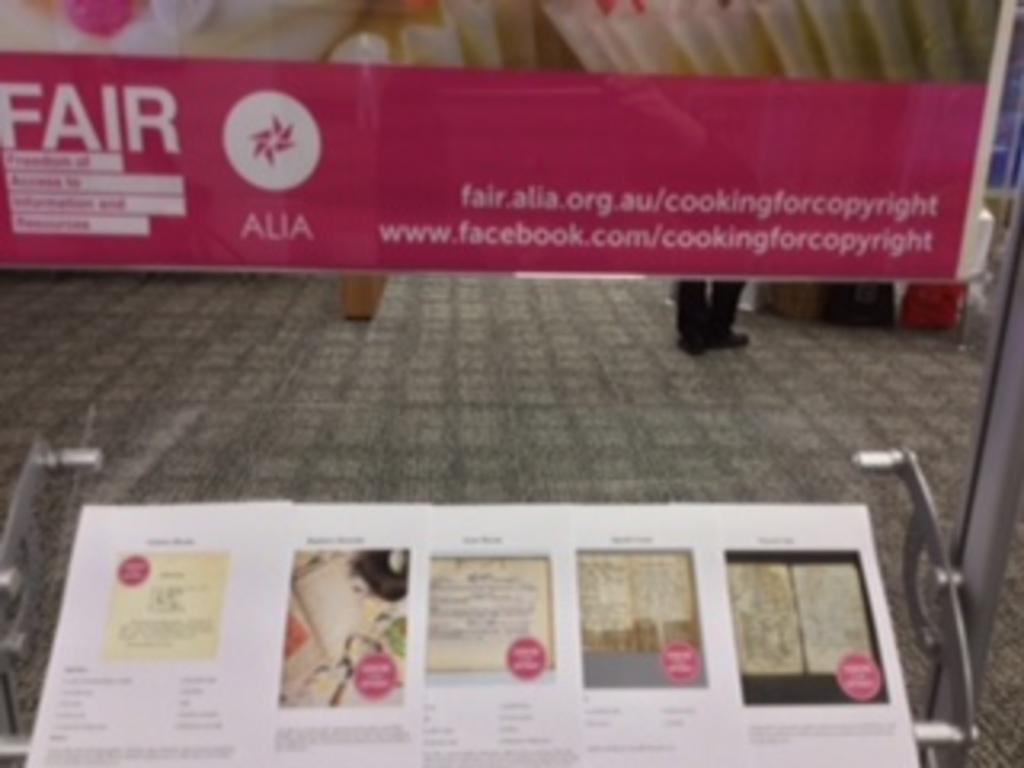What is present on the wall in the image? There is a poster in the image. What is hanging from the ceiling in the image? There is a banner in the image. Can you describe the person in the image? The person is standing behind the banner. What type of whip is being used by the person in the image? There is no whip present in the image. What is the person's reaction to the surprise in the image? There is no surprise or reaction mentioned in the image. 